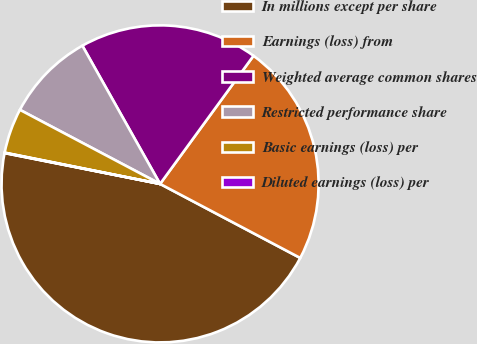Convert chart to OTSL. <chart><loc_0><loc_0><loc_500><loc_500><pie_chart><fcel>In millions except per share<fcel>Earnings (loss) from<fcel>Weighted average common shares<fcel>Restricted performance share<fcel>Basic earnings (loss) per<fcel>Diluted earnings (loss) per<nl><fcel>45.38%<fcel>22.71%<fcel>18.18%<fcel>9.11%<fcel>4.58%<fcel>0.04%<nl></chart> 